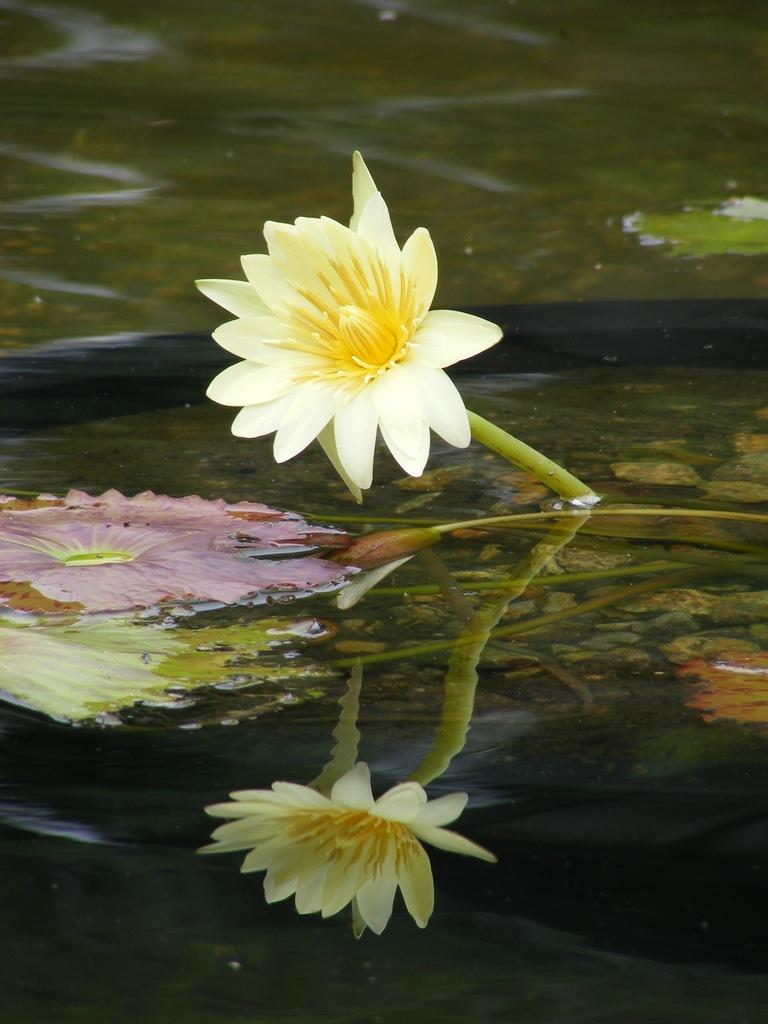What is the main subject of the image? There is a flower in the image. Where is the flower located? The flower is in the water. What can be observed about the flower's reflection in the water? There is a reflection of the flower in the water. What type of copper seat can be seen in the image? There is no copper seat present in the image; it features a flower in the water. 